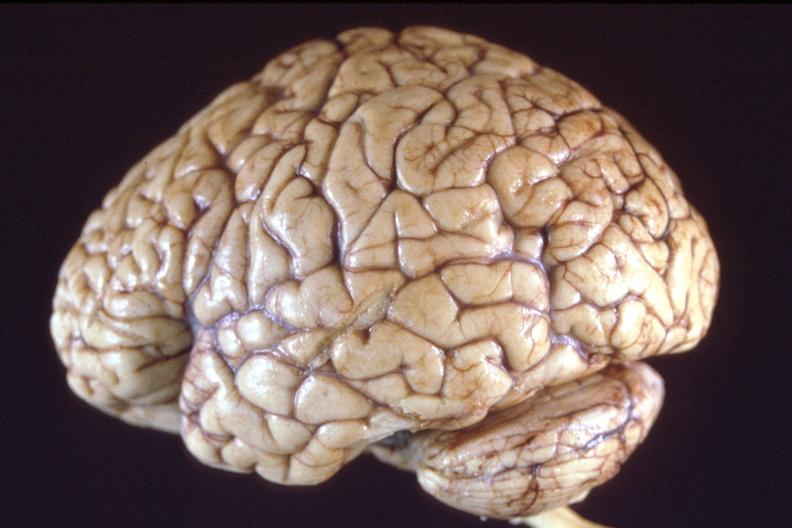does supernumerary digit show brain, breast cancer metastasis to meninges?
Answer the question using a single word or phrase. No 